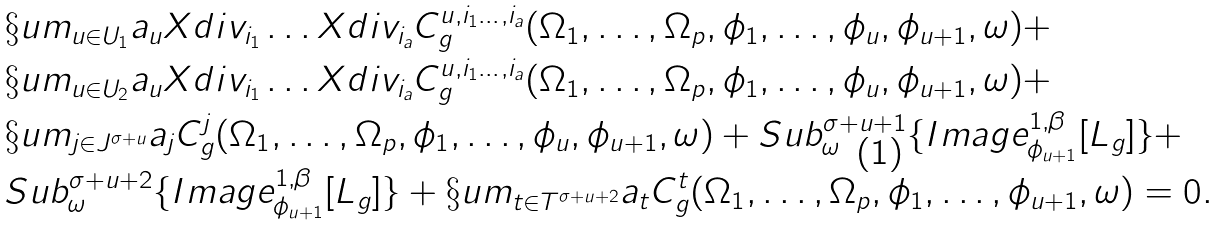<formula> <loc_0><loc_0><loc_500><loc_500>& \S u m _ { u \in U _ { 1 } } a _ { u } X d i v _ { i _ { 1 } } \dots X d i v _ { i _ { a } } C ^ { u , i _ { 1 } \dots , i _ { a } } _ { g } ( \Omega _ { 1 } , \dots , \Omega _ { p } , \phi _ { 1 } , \dots , \phi _ { u } , \phi _ { u + 1 } , \omega ) + \\ & \S u m _ { u \in U _ { 2 } } a _ { u } X d i v _ { i _ { 1 } } \dots X d i v _ { i _ { a } } C ^ { u , i _ { 1 } \dots , i _ { a } } _ { g } ( \Omega _ { 1 } , \dots , \Omega _ { p } , \phi _ { 1 } , \dots , \phi _ { u } , \phi _ { u + 1 } , \omega ) + \\ & \S u m _ { j \in J ^ { \sigma + u } } a _ { j } C ^ { j } _ { g } ( \Omega _ { 1 } , \dots , \Omega _ { p } , \phi _ { 1 } , \dots , \phi _ { u } , \phi _ { u + 1 } , \omega ) + S u b ^ { \sigma + u + 1 } _ { \omega } \{ I m a g e ^ { 1 , \beta } _ { \phi _ { u + 1 } } [ L _ { g } ] \} + \\ & S u b ^ { \sigma + u + 2 } _ { \omega } \{ I m a g e ^ { 1 , \beta } _ { \phi _ { u + 1 } } [ L _ { g } ] \} + \S u m _ { t \in T ^ { \sigma + u + 2 } } a _ { t } C ^ { t } _ { g } ( \Omega _ { 1 } , \dots , \Omega _ { p } , \phi _ { 1 } , \dots , \phi _ { u + 1 } , \omega ) = 0 .</formula> 